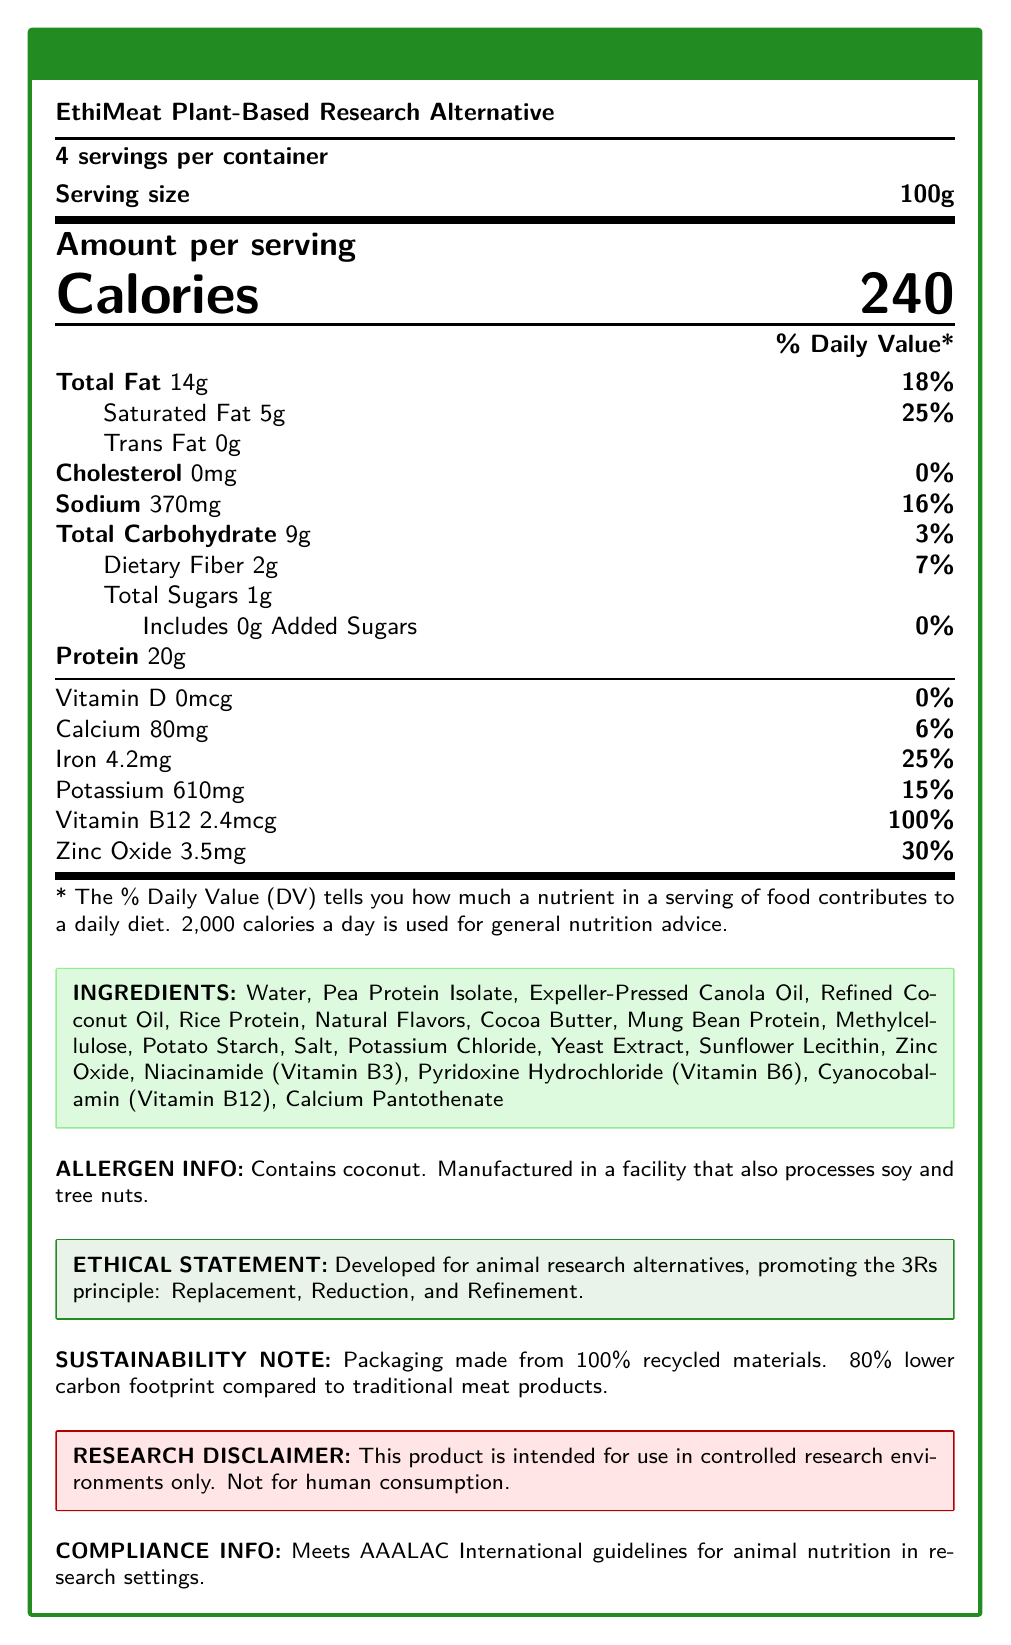what is the serving size? According to the document, the serving size for the EthiMeat Plant-Based Research Alternative is 100 grams.
Answer: 100g how many servings are in the container? The document indicates that there are 4 servings per container.
Answer: 4 what are the calories per serving? The number of calories per serving is listed as 240.
Answer: 240 what amount of protein does one serving contain? The nutrition facts state that one serving contains 20 grams of protein.
Answer: 20g what is the total fat percentage of the Daily Value? The Total Fat amount per serving is 14g, which is 18% of the Daily Value.
Answer: 18% what allergens are included in the product? The allergen information notes that the product contains coconut and is manufactured in a facility that also processes soy and tree nuts.
Answer: Coconut which nutrient has the highest percentage of the Daily Value in one serving? A. Vitamin D B. Iron C. Vitamin B12 D. Calcium According to the nutrition facts, Vitamin B12 comprises 100% of the Daily Value per serving.
Answer: C. Vitamin B12 which of the following is NOT an ingredient in the product? A. Pea Protein Isolate B. Expeller-Pressed Canola Oil C. Soy Protein D. Cocoa Butter Soy Protein is not listed in the ingredients, while Pea Protein Isolate, Expeller-Pressed Canola Oil, and Cocoa Butter are included.
Answer: C. Soy Protein does the product contain cholesterol? The document confirms that the product contains 0mg of cholesterol, which is 0% of the Daily Value.
Answer: No summarize the main ideas of the document. This summary captures the comprehensive data provided about the product, emphasizing its nutritional content, ethical compliance, and environmental sustainability aspects.
Answer: The document provides detailed nutritional information for EthiMeat Plant-Based Research Alternative, including serving size, calories, and percentages of daily values for various nutrients. It lists the ingredients, allergen information, ethical statement, sustainability note, research disclaimer, and compliance with AAALAC International guidelines for animal nutrition in research settings. what are the three guiding principles in the ethical statement for this product? The document states that the product is developed for animal research alternatives, promoting the 3Rs principle: Replacement, Reduction, and Refinement.
Answer: Replacement, Reduction, and Refinement what percentage of the Daily Value for iron does the product contain per serving? The document indicates that iron is present at 4.2mg per serving, corresponding to 25% of the Daily Value.
Answer: 25% how many grams of dietary fiber are in one serving? The nutritional information shows that one serving contains 2 grams of dietary fiber.
Answer: 2g by what percentage is the carbon footprint lower compared to traditional meat products? The sustainability note mentions that the product has an 80% lower carbon footprint compared to traditional meat products.
Answer: 80% is this product intended for human consumption? The research disclaimer explicitly states that this product is intended for use in controlled research environments only and is not for human consumption.
Answer: No how many recycled materials were used for packaging? The document only states that the packaging is made from 100% recycled materials but does not quantify the materials used.
Answer: Not enough information 